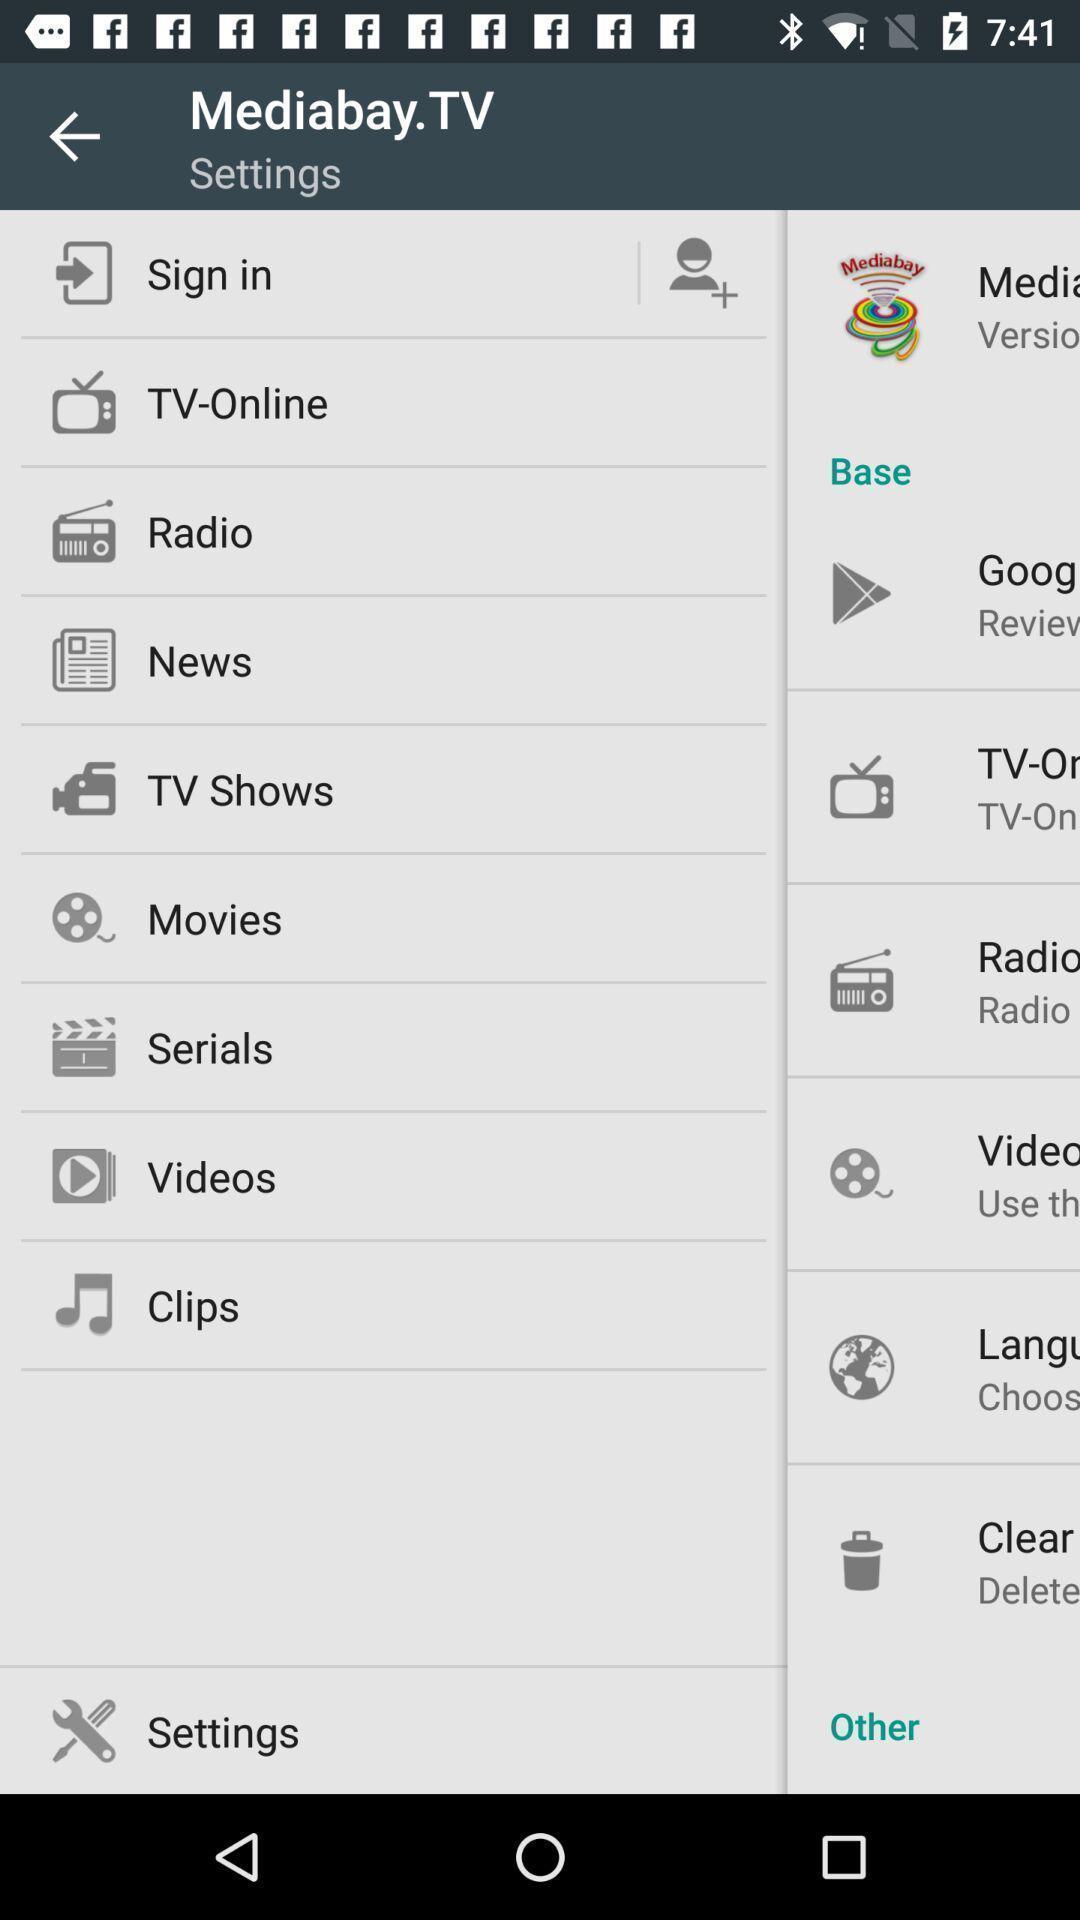What can you discern from this picture? Page showing different options in settings. 